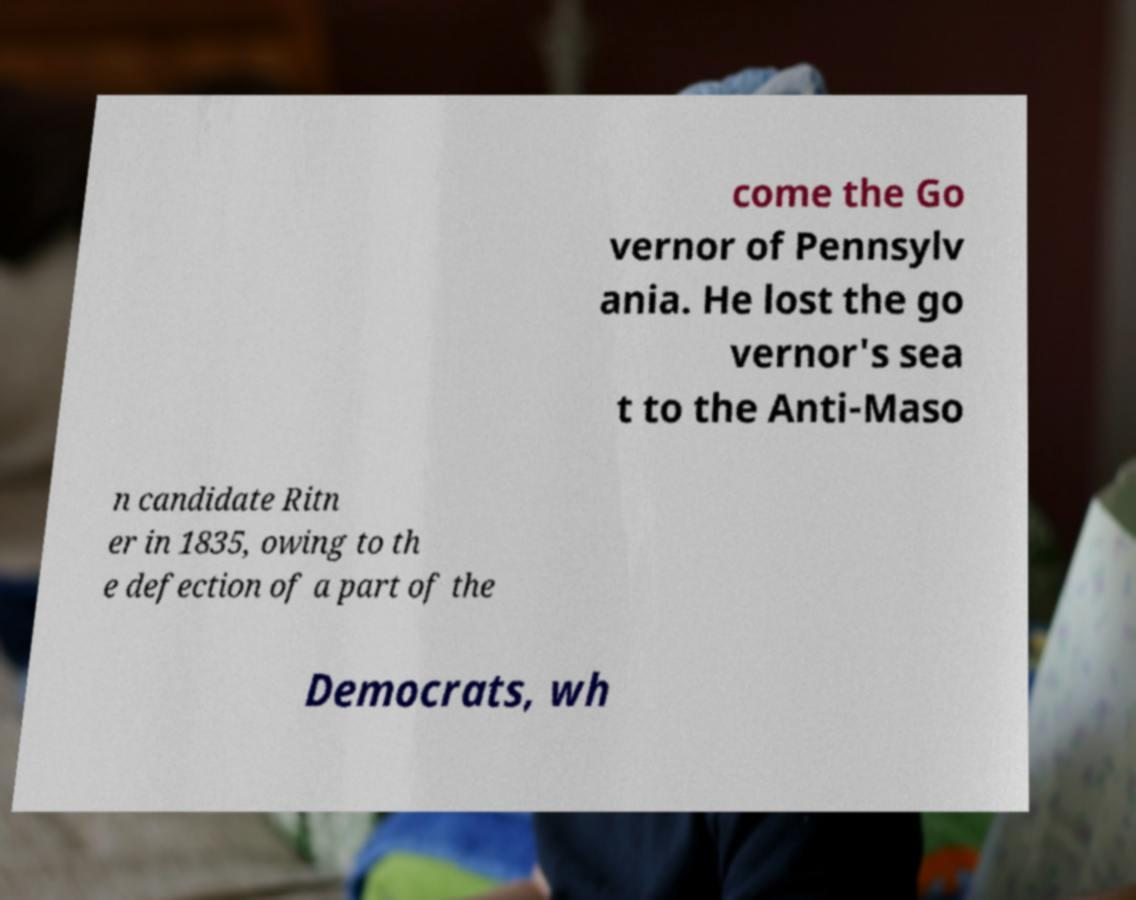There's text embedded in this image that I need extracted. Can you transcribe it verbatim? come the Go vernor of Pennsylv ania. He lost the go vernor's sea t to the Anti-Maso n candidate Ritn er in 1835, owing to th e defection of a part of the Democrats, wh 